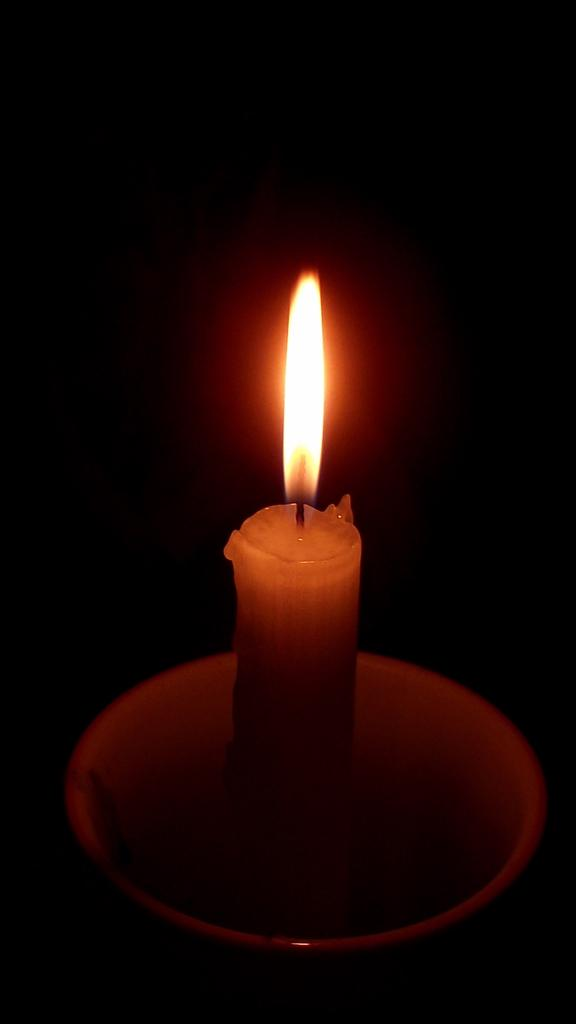What is the main object in the image? There is a candle in the image. Where is the candle located? The candle is in an object. What can be observed about the background of the image? The background of the image is dark. What does the mother do to stretch the hot candle in the image? There is no mother, stretching, or hot candle present in the image. 